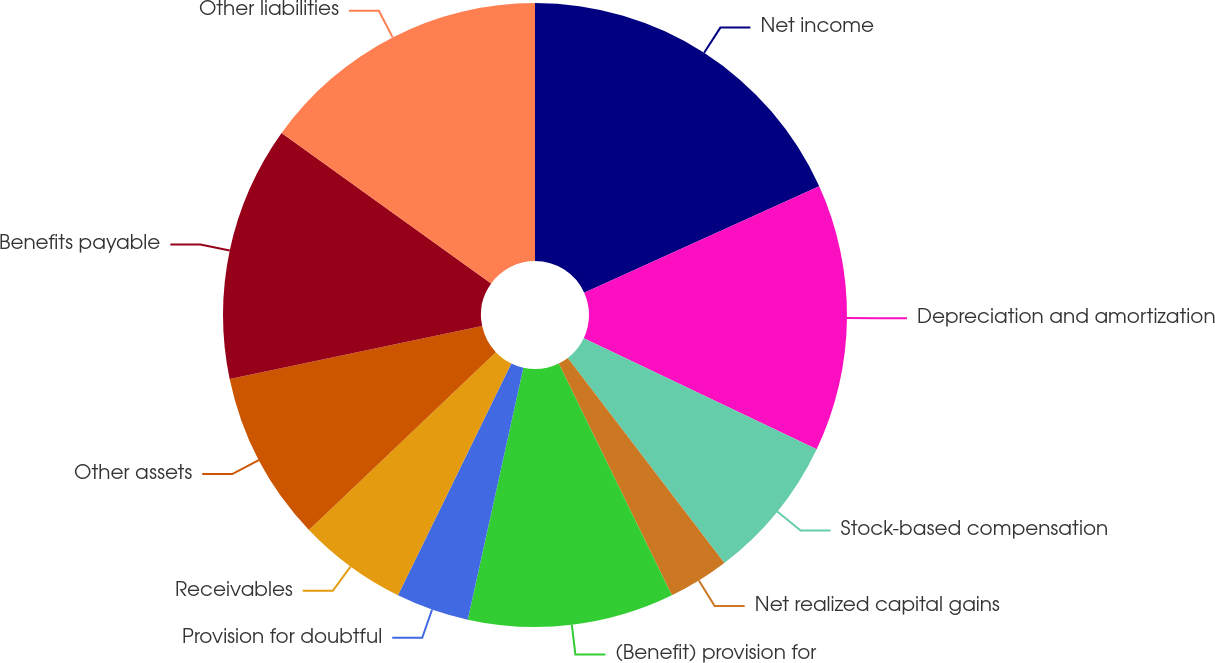Convert chart to OTSL. <chart><loc_0><loc_0><loc_500><loc_500><pie_chart><fcel>Net income<fcel>Depreciation and amortization<fcel>Stock-based compensation<fcel>Net realized capital gains<fcel>(Benefit) provision for<fcel>Provision for doubtful<fcel>Receivables<fcel>Other assets<fcel>Benefits payable<fcel>Other liabilities<nl><fcel>18.24%<fcel>13.84%<fcel>7.55%<fcel>3.15%<fcel>10.69%<fcel>3.78%<fcel>5.66%<fcel>8.81%<fcel>13.21%<fcel>15.09%<nl></chart> 